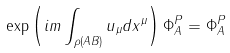<formula> <loc_0><loc_0><loc_500><loc_500>\exp \left ( i m \int _ { \rho ( A B ) } u _ { \mu } d x ^ { \mu } \right ) \Phi _ { A } ^ { P } = \Phi _ { A } ^ { P }</formula> 